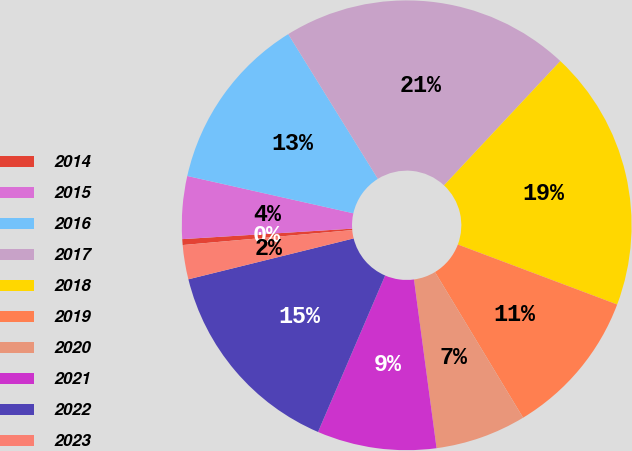<chart> <loc_0><loc_0><loc_500><loc_500><pie_chart><fcel>2014<fcel>2015<fcel>2016<fcel>2017<fcel>2018<fcel>2019<fcel>2020<fcel>2021<fcel>2022<fcel>2023<nl><fcel>0.42%<fcel>4.5%<fcel>12.65%<fcel>20.8%<fcel>18.76%<fcel>10.61%<fcel>6.54%<fcel>8.57%<fcel>14.69%<fcel>2.46%<nl></chart> 